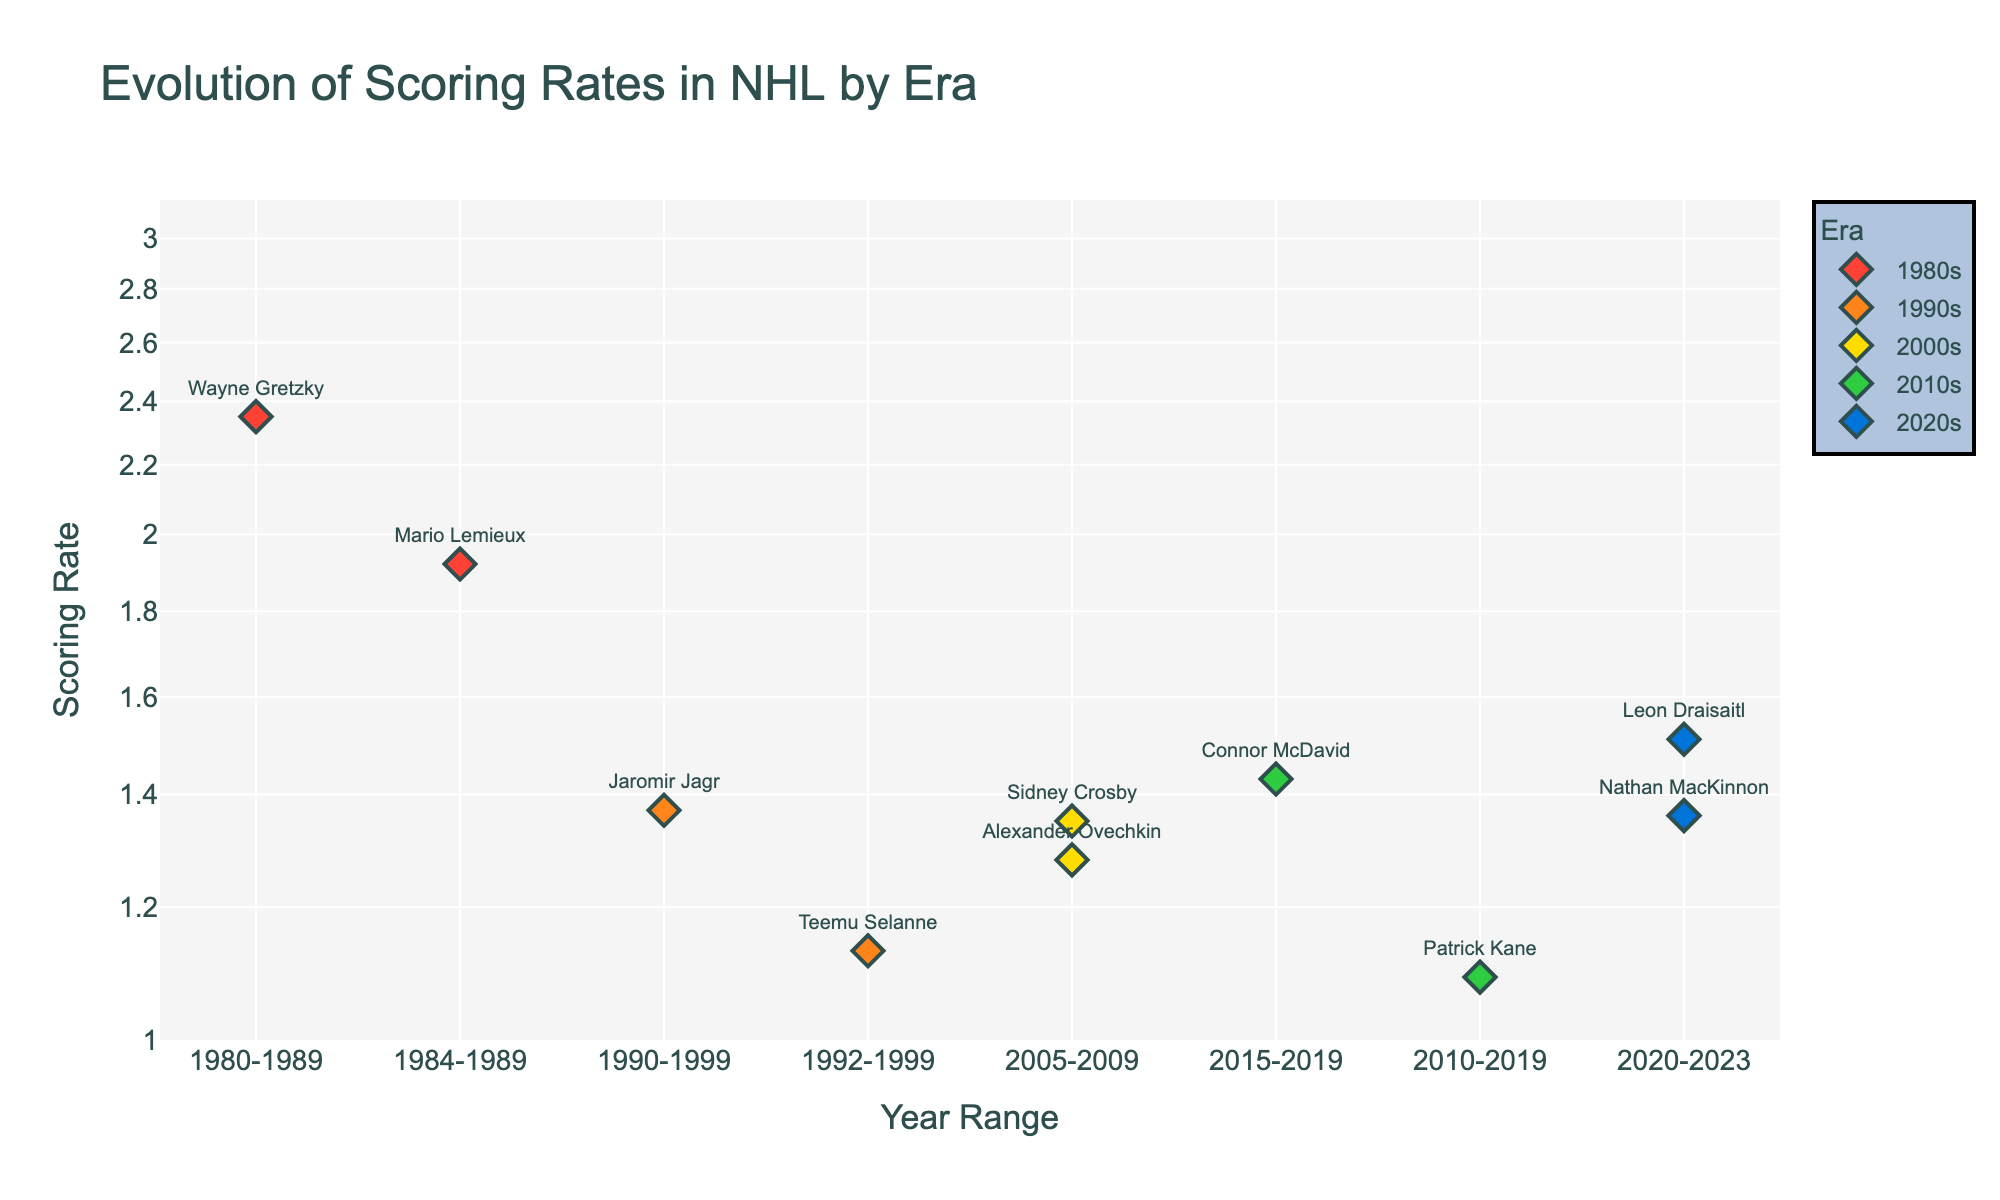What is the title of the figure? The title is typically placed prominently at the top of the figure. Here, it reads "Evolution of Scoring Rates in NHL by Era."
Answer: Evolution of Scoring Rates in NHL by Era How many eras are represented in the figure? Looking at the legend or the different colors used in the figure, we can observe six distinct eras.
Answer: Six Which player had the highest scoring rate in the 1980s? By examining the markers labeled with player names in the 1980s section, Wayne Gretzky is seen to have the highest scoring rate of 2.35.
Answer: Wayne Gretzky Who had a higher scoring rate in the 2020s, Leon Draisaitl or Nathan MacKinnon? By comparing the markers labeled with their names in the 2020s section, we can see that Leon Draisaitl's scoring rate of 1.51 is higher than Nathan MacKinnon's 1.36.
Answer: Leon Draisaitl What is the range of the y-axis? The y-axis is set to a log scale, and the increments indicate a range from a bit below 1 to a bit above 2. This is confirmed by the `fig.update_yaxes` setting in the code.
Answer: Approximately 1 to 2 How does the scoring rate of Jaromir Jagr in the 1990s compare to Connor McDavid in the 2010s? By comparing the positions of the markers labeled Jaromir Jagr and Connor McDavid, we see Jagr's rate (1.37) is slightly lower than McDavid's (1.43).
Answer: McDavid's is higher Which era has the most players with a scoring rate below 1.5? From the figure, we can observe that the 1990s and 2010s each have two players below 1.5: Jagr and Selanne (1990s) and Kane and McDavid (2010s). No other era has more than one.
Answer: 1990s and 2010s Do any players from the 2000s have a scoring rate higher than 1.3? By examining the markers in the 2000s section, both Alexander Ovechkin (1.28) and Sidney Crosby (1.35) are visible, with Crosby surpassing 1.3.
Answer: Sidney Crosby What is the difference in the scoring rate between the highest and lowest scoring players in the 1980s? Wayne Gretzky's scoring rate is 2.35, and Mario Lemieux's is 1.92. The difference is calculated as 2.35 - 1.92.
Answer: 0.43 